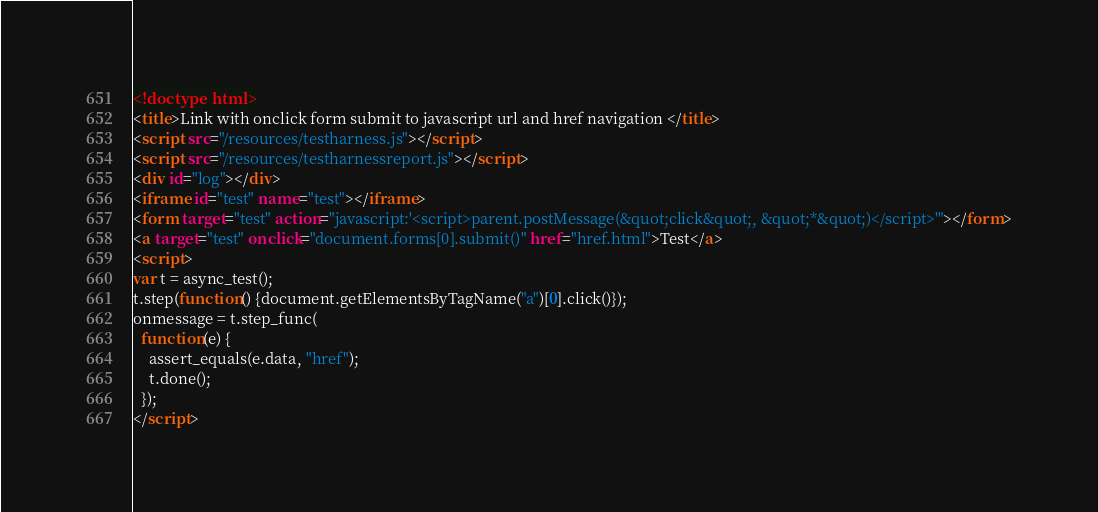<code> <loc_0><loc_0><loc_500><loc_500><_HTML_><!doctype html>
<title>Link with onclick form submit to javascript url and href navigation </title>
<script src="/resources/testharness.js"></script>
<script src="/resources/testharnessreport.js"></script>
<div id="log"></div>
<iframe id="test" name="test"></iframe>
<form target="test" action="javascript:'<script>parent.postMessage(&quot;click&quot;, &quot;*&quot;)</script>'"></form>
<a target="test" onclick="document.forms[0].submit()" href="href.html">Test</a>
<script>
var t = async_test();
t.step(function() {document.getElementsByTagName("a")[0].click()});
onmessage = t.step_func(
  function(e) {
    assert_equals(e.data, "href"); 
    t.done();
  });
</script>
</code> 